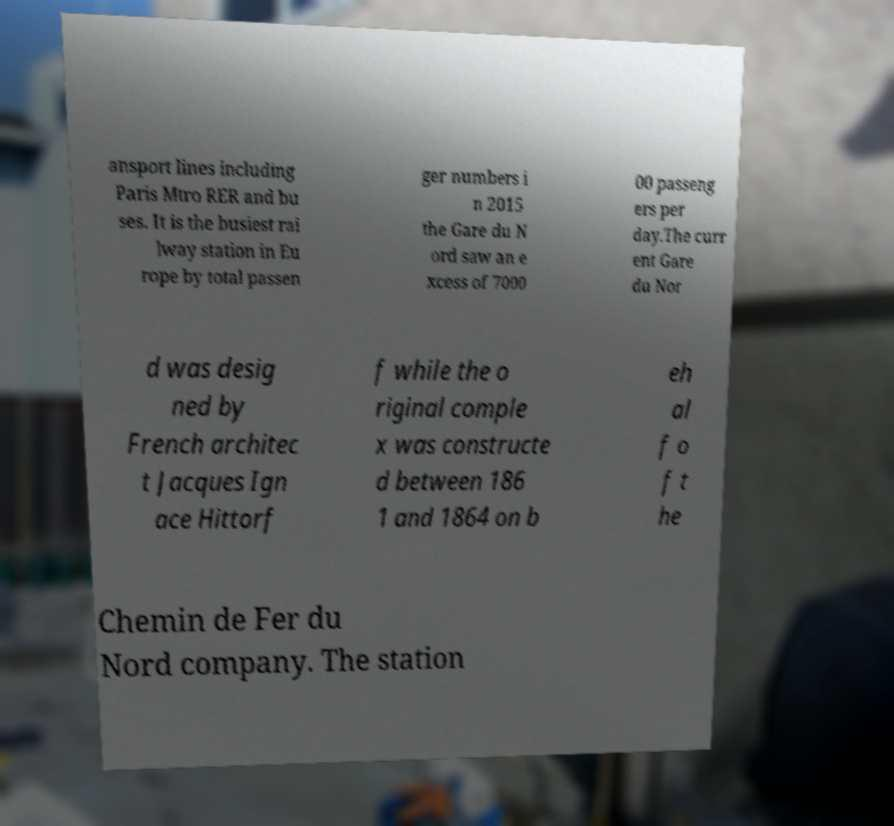Can you read and provide the text displayed in the image?This photo seems to have some interesting text. Can you extract and type it out for me? ansport lines including Paris Mtro RER and bu ses. It is the busiest rai lway station in Eu rope by total passen ger numbers i n 2015 the Gare du N ord saw an e xcess of 7000 00 passeng ers per day.The curr ent Gare du Nor d was desig ned by French architec t Jacques Ign ace Hittorf f while the o riginal comple x was constructe d between 186 1 and 1864 on b eh al f o f t he Chemin de Fer du Nord company. The station 